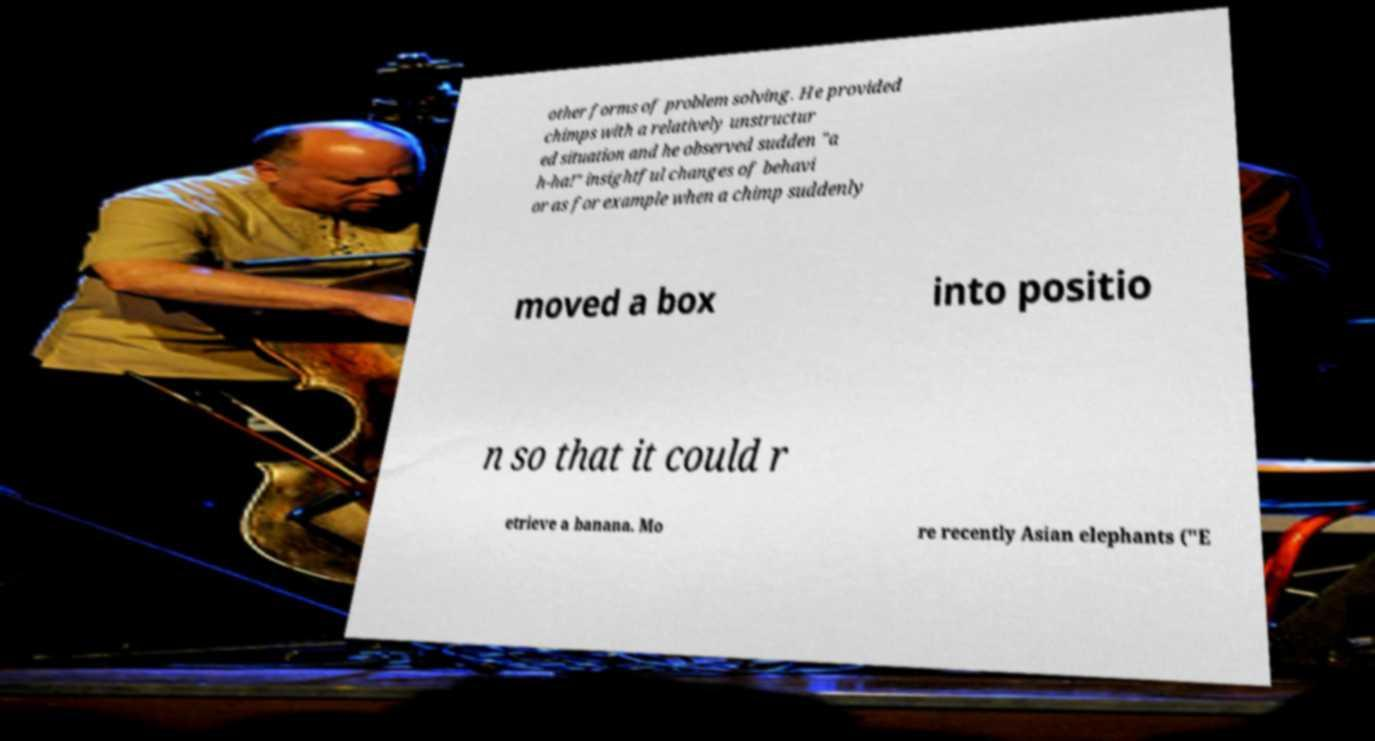For documentation purposes, I need the text within this image transcribed. Could you provide that? other forms of problem solving. He provided chimps with a relatively unstructur ed situation and he observed sudden "a h-ha!" insightful changes of behavi or as for example when a chimp suddenly moved a box into positio n so that it could r etrieve a banana. Mo re recently Asian elephants ("E 